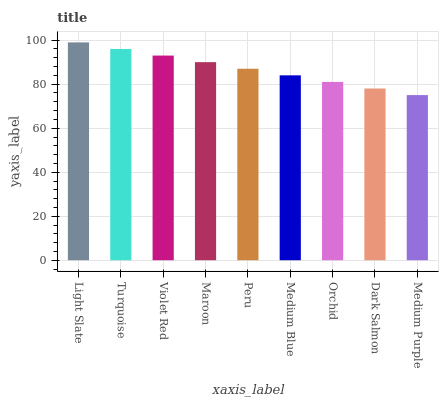Is Medium Purple the minimum?
Answer yes or no. Yes. Is Light Slate the maximum?
Answer yes or no. Yes. Is Turquoise the minimum?
Answer yes or no. No. Is Turquoise the maximum?
Answer yes or no. No. Is Light Slate greater than Turquoise?
Answer yes or no. Yes. Is Turquoise less than Light Slate?
Answer yes or no. Yes. Is Turquoise greater than Light Slate?
Answer yes or no. No. Is Light Slate less than Turquoise?
Answer yes or no. No. Is Peru the high median?
Answer yes or no. Yes. Is Peru the low median?
Answer yes or no. Yes. Is Turquoise the high median?
Answer yes or no. No. Is Turquoise the low median?
Answer yes or no. No. 